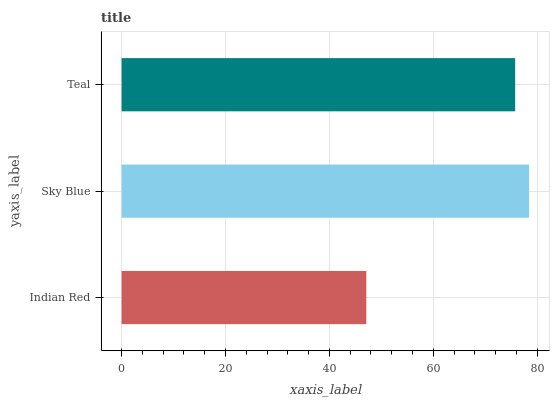Is Indian Red the minimum?
Answer yes or no. Yes. Is Sky Blue the maximum?
Answer yes or no. Yes. Is Teal the minimum?
Answer yes or no. No. Is Teal the maximum?
Answer yes or no. No. Is Sky Blue greater than Teal?
Answer yes or no. Yes. Is Teal less than Sky Blue?
Answer yes or no. Yes. Is Teal greater than Sky Blue?
Answer yes or no. No. Is Sky Blue less than Teal?
Answer yes or no. No. Is Teal the high median?
Answer yes or no. Yes. Is Teal the low median?
Answer yes or no. Yes. Is Sky Blue the high median?
Answer yes or no. No. Is Indian Red the low median?
Answer yes or no. No. 